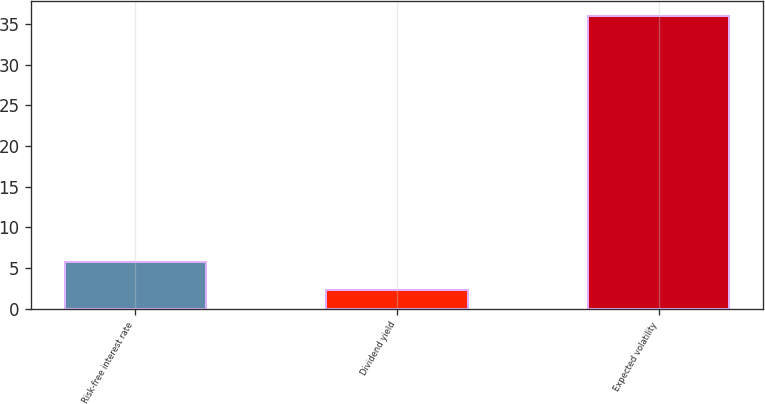<chart> <loc_0><loc_0><loc_500><loc_500><bar_chart><fcel>Risk-free interest rate<fcel>Dividend yield<fcel>Expected volatility<nl><fcel>5.7<fcel>2.33<fcel>36<nl></chart> 